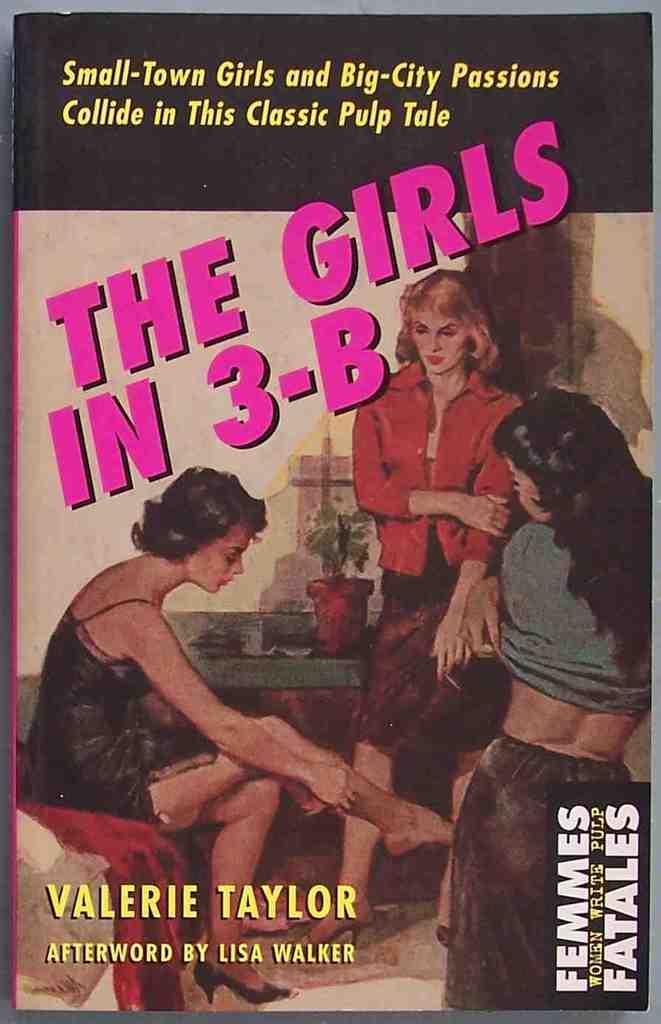What is the title of this story?
Provide a succinct answer. The girls in 3-b. Who authored the book?
Ensure brevity in your answer.  Valerie taylor. 